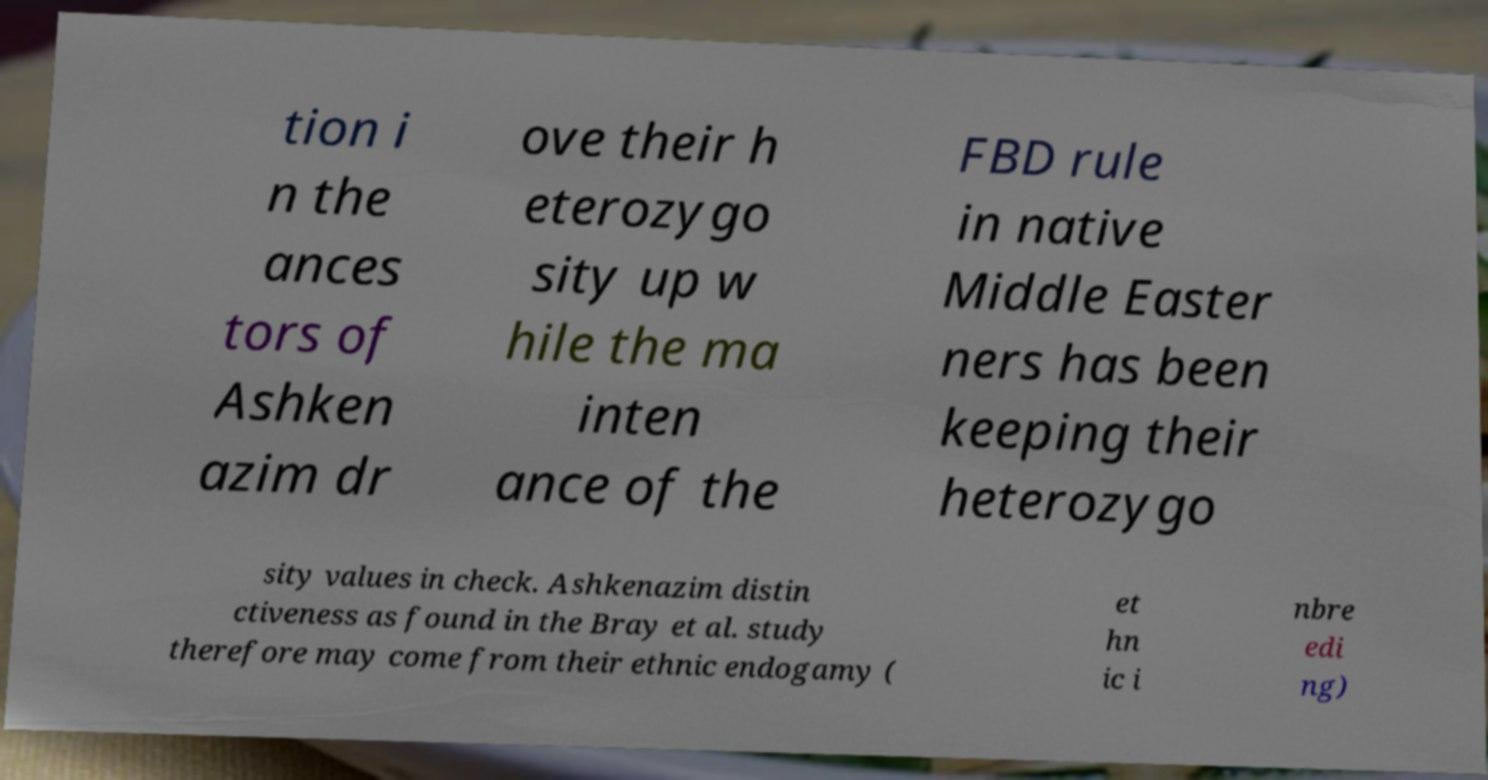Can you accurately transcribe the text from the provided image for me? tion i n the ances tors of Ashken azim dr ove their h eterozygo sity up w hile the ma inten ance of the FBD rule in native Middle Easter ners has been keeping their heterozygo sity values in check. Ashkenazim distin ctiveness as found in the Bray et al. study therefore may come from their ethnic endogamy ( et hn ic i nbre edi ng) 